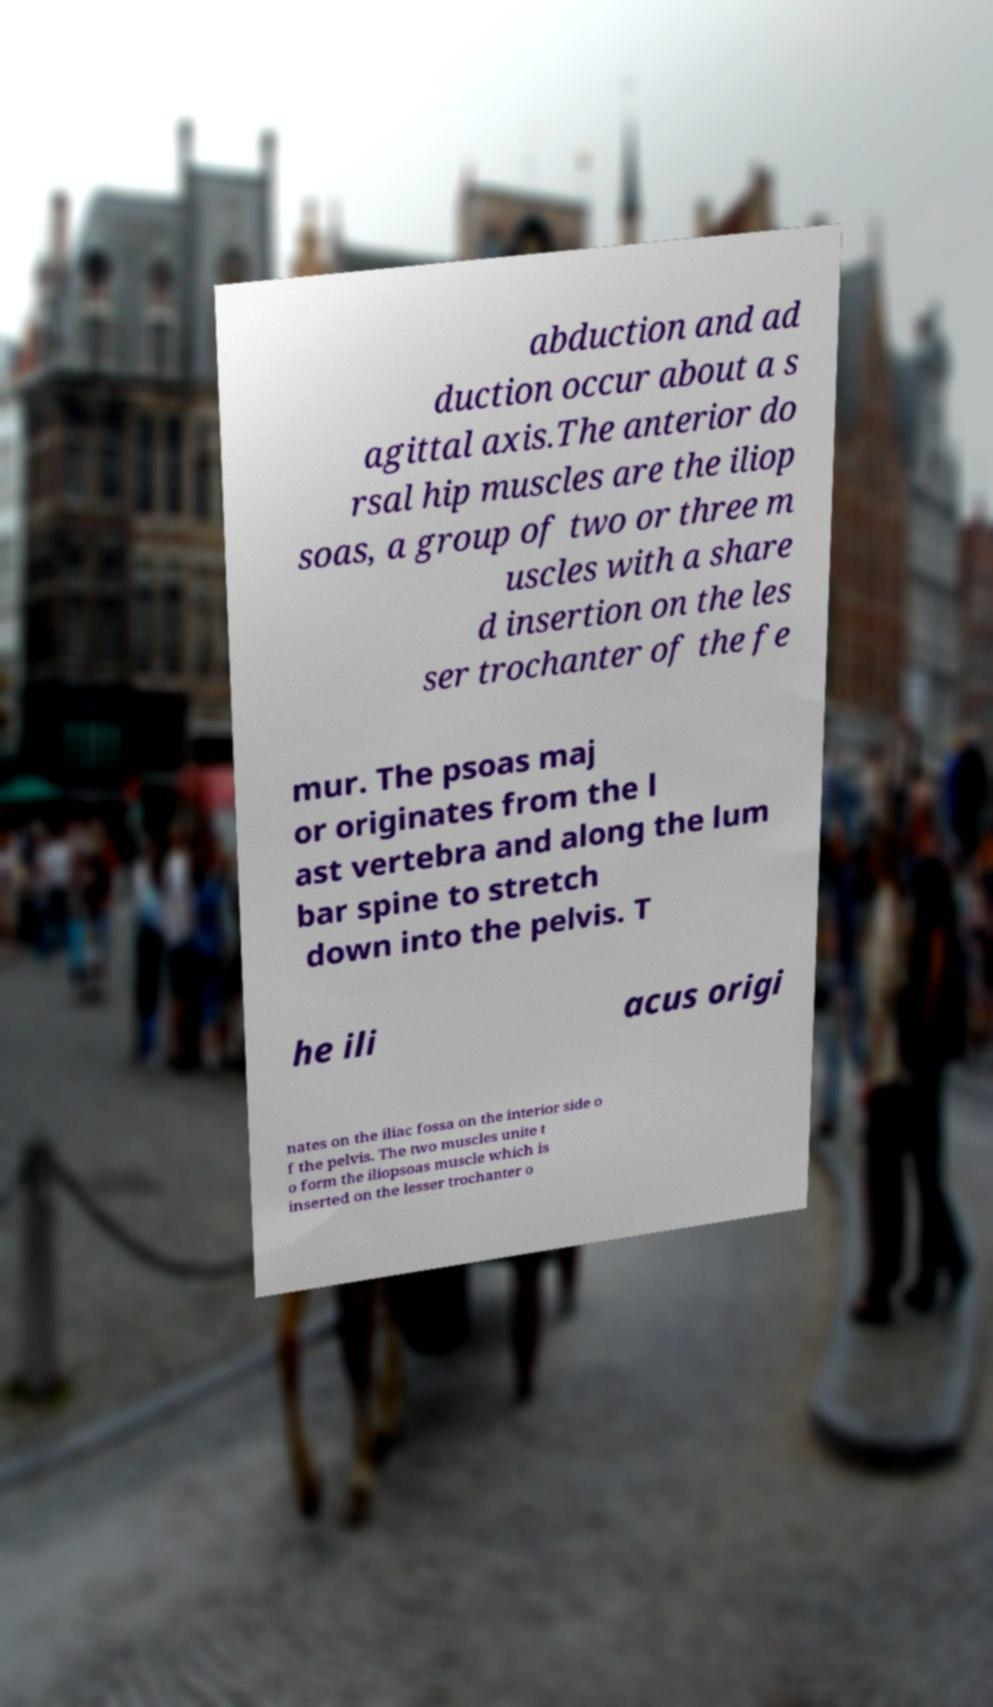Please identify and transcribe the text found in this image. abduction and ad duction occur about a s agittal axis.The anterior do rsal hip muscles are the iliop soas, a group of two or three m uscles with a share d insertion on the les ser trochanter of the fe mur. The psoas maj or originates from the l ast vertebra and along the lum bar spine to stretch down into the pelvis. T he ili acus origi nates on the iliac fossa on the interior side o f the pelvis. The two muscles unite t o form the iliopsoas muscle which is inserted on the lesser trochanter o 